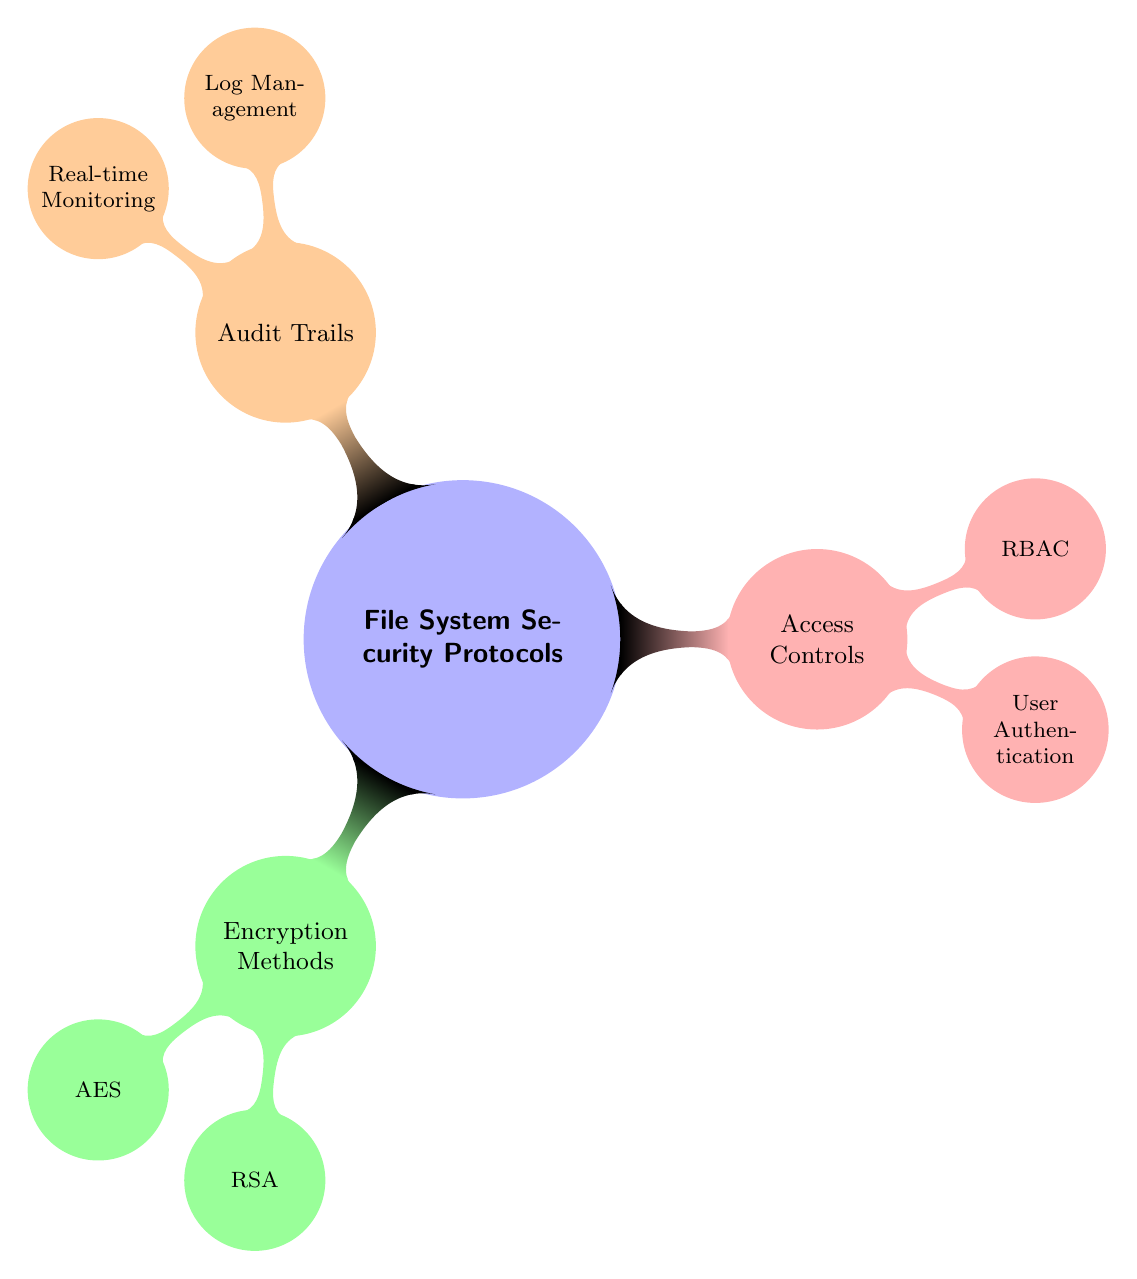What are the three main categories of file system security protocols depicted in the diagram? The diagram explicitly shows three primary categories branching from the central concept "File System Security Protocols." These are "Encryption Methods," "Access Controls," and "Audit Trails."
Answer: Encryption Methods, Access Controls, Audit Trails How many encryption methods are listed in the diagram? The diagram displays two encryption methods under the "Encryption Methods" category: "AES" and "RSA." Thus, counting these, the total is two.
Answer: 2 What type of access control method is represented alongside user authentication? In the "Access Controls" category, the diagram lists "RBAC" alongside "User Authentication," indicating that both are recognized methods for regulating access rights.
Answer: RBAC Which subcategory under audit trails includes real-time monitoring? "Real-time Monitoring" is shown as a child node under the "Audit Trails" category, indicating that it falls within this subcategory related to observing system activity.
Answer: Real-time Monitoring How does the diagram categorize the method of user authentication? Within the "Access Controls" section, "User Authentication" is displayed as a specific method to verify users' identities, categorizing it as a necessary component of access control mechanisms by the diagram's structure.
Answer: Access Controls Explain the relationship between encryption methods and access controls. The diagram illustrates that both "Encryption Methods" and "Access Controls" are separate branches stemming from the main concept of file system security protocols. This indicates that they are distinct categories, but both contribute to overall security measures within file systems.
Answer: Separate categories Which encryption method is a symmetric algorithm? Among the encryption methods listed, "AES" is known as a symmetric encryption algorithm, while "RSA" is an asymmetric algorithm. The diagram supports this classification by listing both separately under "Encryption Methods."
Answer: AES What is the purpose of audit trails as depicted in the diagram? The diagram suggests that "Audit Trails" are for tracking activities on the system, which is broken down into concepts like "Log Management" and "Real-time Monitoring," reflecting their purpose of maintaining security oversight.
Answer: Tracking activities 